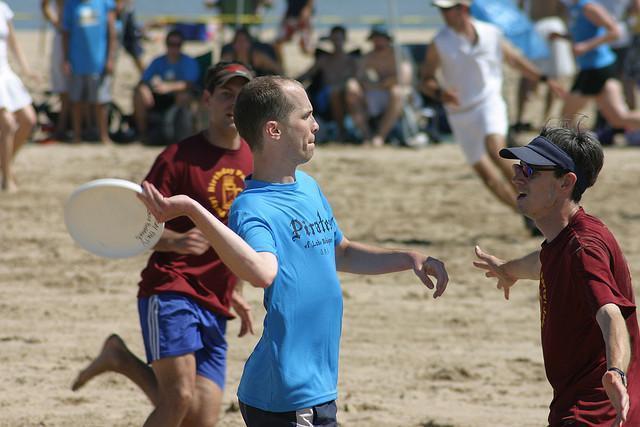How many hats do you see?
Give a very brief answer. 3. How many people are there?
Give a very brief answer. 11. How many spoons are in the picture?
Give a very brief answer. 0. 